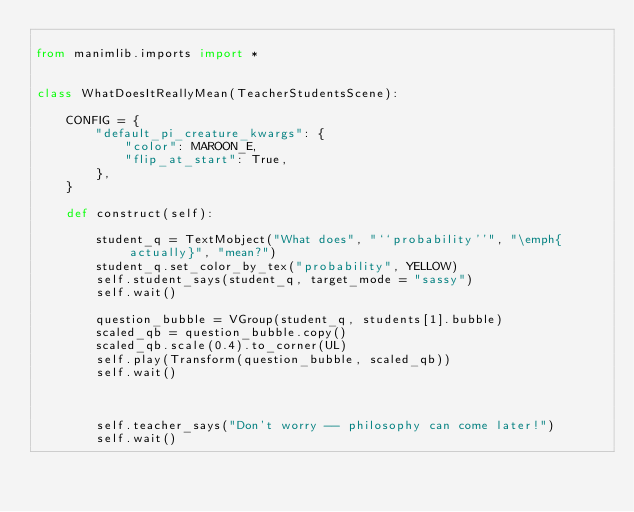Convert code to text. <code><loc_0><loc_0><loc_500><loc_500><_Python_>
from manimlib.imports import *


class WhatDoesItReallyMean(TeacherStudentsScene):

    CONFIG = {
        "default_pi_creature_kwargs": {
            "color": MAROON_E,
            "flip_at_start": True,
        },
    }

    def construct(self):

        student_q = TextMobject("What does", "``probability''", "\emph{actually}", "mean?")
        student_q.set_color_by_tex("probability", YELLOW)
        self.student_says(student_q, target_mode = "sassy")
        self.wait()

        question_bubble = VGroup(student_q, students[1].bubble)
        scaled_qb = question_bubble.copy()
        scaled_qb.scale(0.4).to_corner(UL)
        self.play(Transform(question_bubble, scaled_qb))
        self.wait()



        self.teacher_says("Don't worry -- philosophy can come later!")
        self.wait()

</code> 